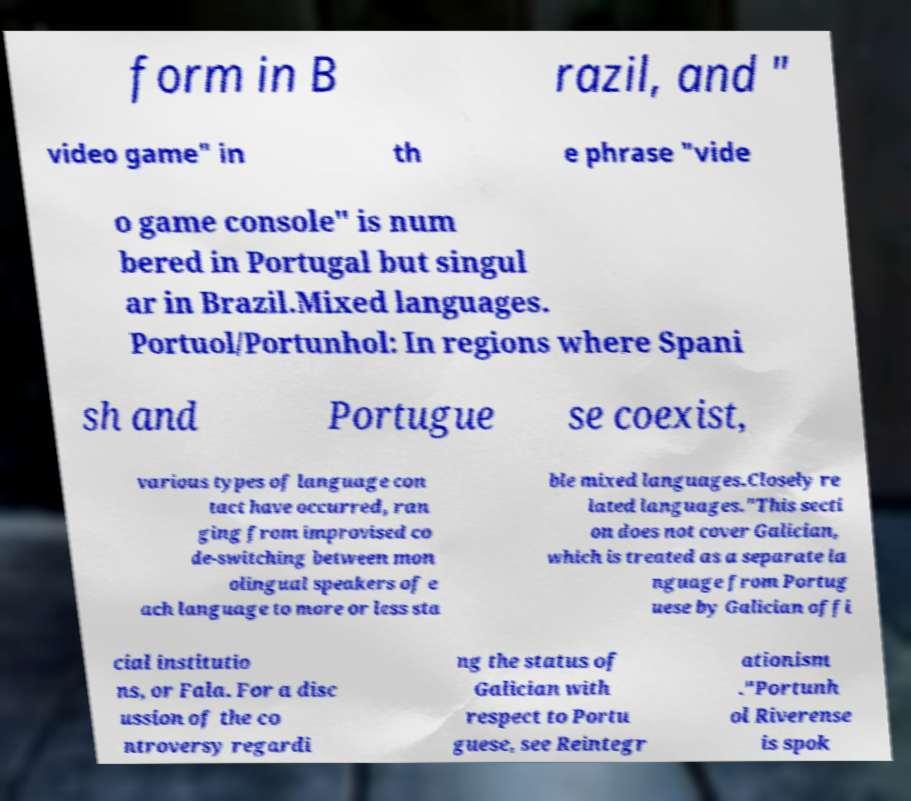What messages or text are displayed in this image? I need them in a readable, typed format. form in B razil, and " video game" in th e phrase "vide o game console" is num bered in Portugal but singul ar in Brazil.Mixed languages. Portuol/Portunhol: In regions where Spani sh and Portugue se coexist, various types of language con tact have occurred, ran ging from improvised co de-switching between mon olingual speakers of e ach language to more or less sta ble mixed languages.Closely re lated languages."This secti on does not cover Galician, which is treated as a separate la nguage from Portug uese by Galician offi cial institutio ns, or Fala. For a disc ussion of the co ntroversy regardi ng the status of Galician with respect to Portu guese, see Reintegr ationism ."Portunh ol Riverense is spok 